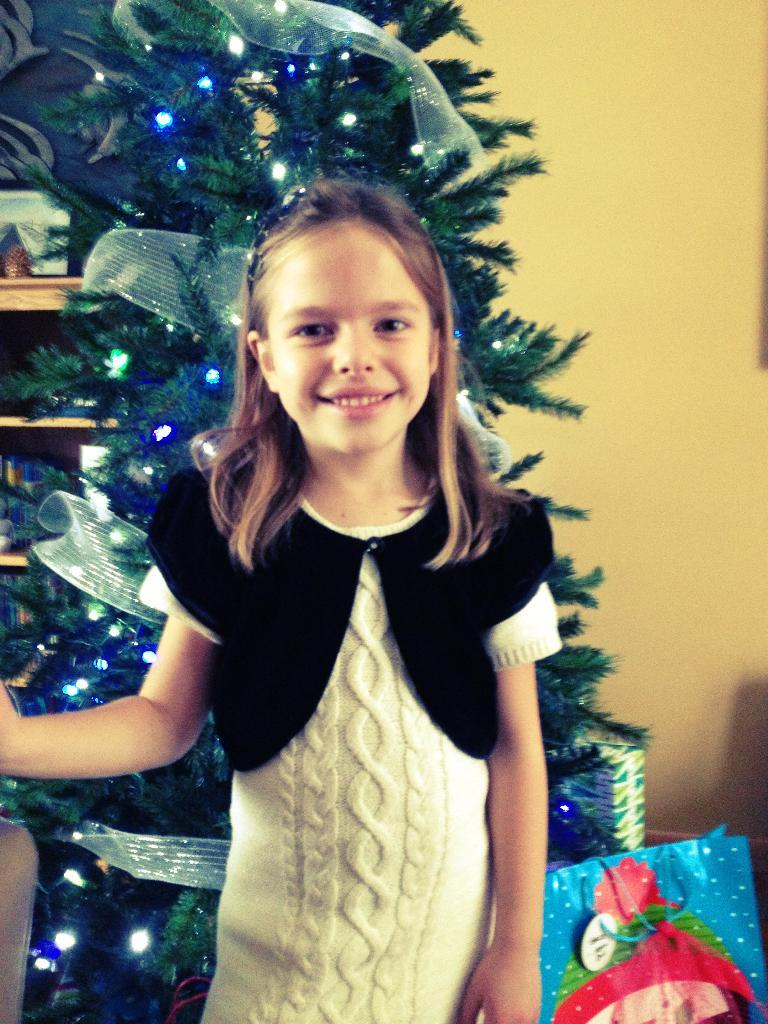What is the main subject of the image? There is a person standing in the image. Can you describe the person's attire? The person is wearing a white and black color dress. What can be seen in the background of the image? There is a Christmas tree and a wall in the background of the image. What color is the Christmas tree? The Christmas tree is green. What color is the wall? The wall is yellow. How many pears are hanging from the wall in the image? There are no pears present in the image; the wall is yellow and there is a person and a Christmas tree in the background. 